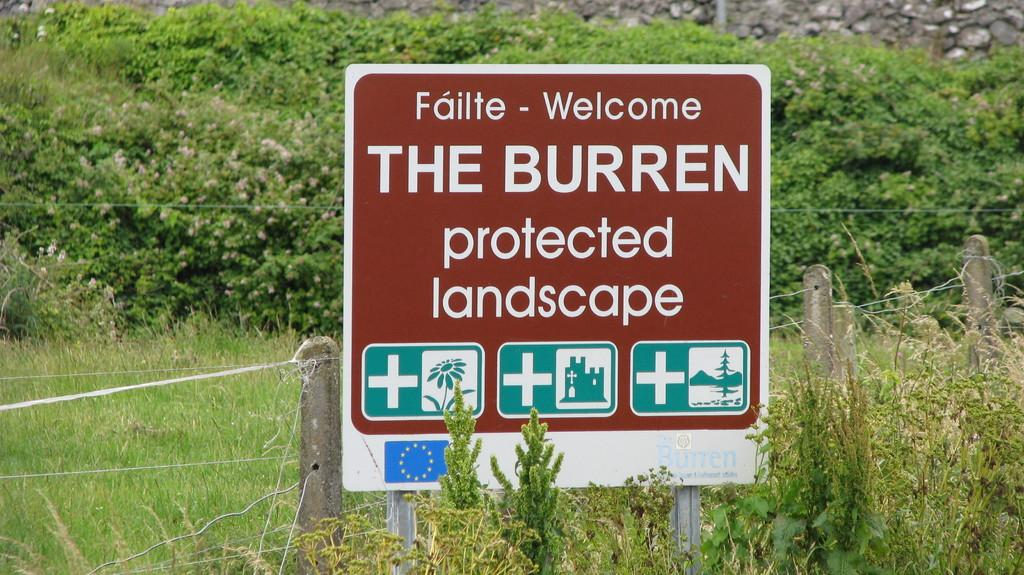<image>
Present a compact description of the photo's key features. A welcome sign for The Burren protected landscape is in front of a fence. 